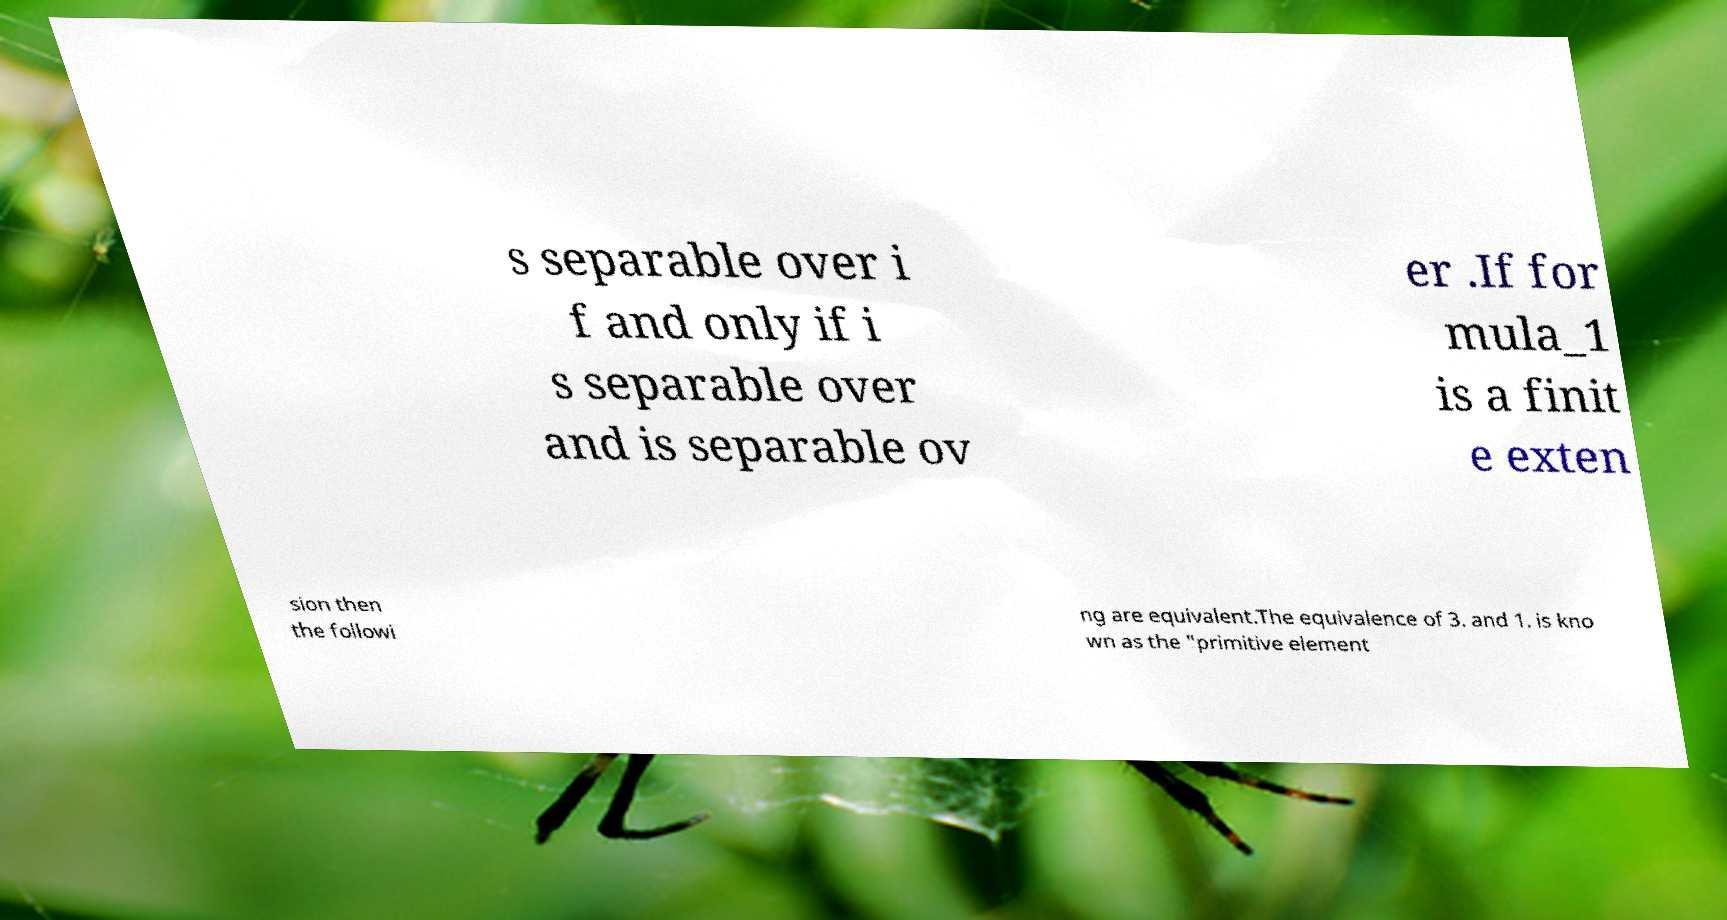Can you accurately transcribe the text from the provided image for me? s separable over i f and only if i s separable over and is separable ov er .If for mula_1 is a finit e exten sion then the followi ng are equivalent.The equivalence of 3. and 1. is kno wn as the "primitive element 